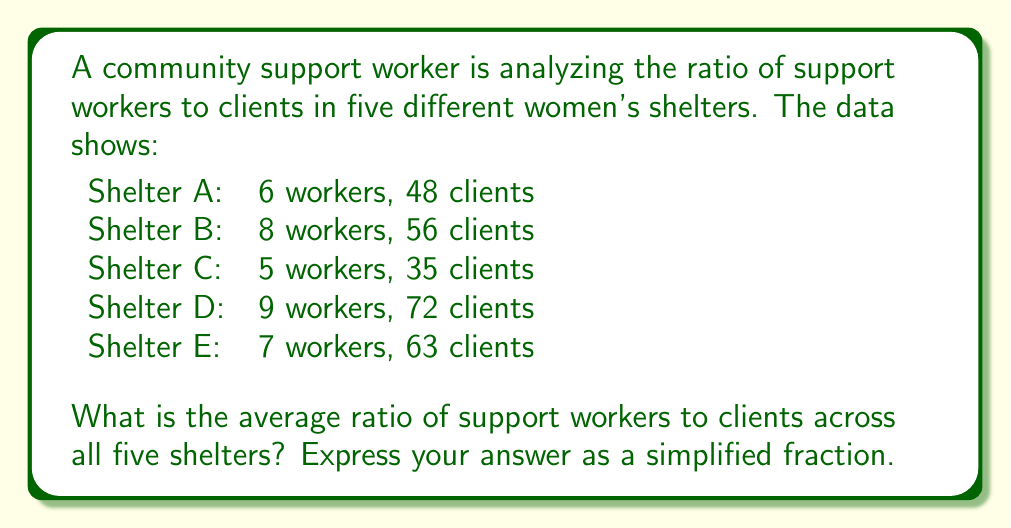Can you answer this question? 1) First, we need to calculate the ratio of workers to clients for each shelter:

   Shelter A: $\frac{6}{48} = \frac{1}{8}$
   Shelter B: $\frac{8}{56} = \frac{1}{7}$
   Shelter C: $\frac{5}{35} = \frac{1}{7}$
   Shelter D: $\frac{9}{72} = \frac{1}{8}$
   Shelter E: $\frac{7}{63} = \frac{1}{9}$

2) To find the average ratio, we sum these fractions and divide by the number of shelters:

   $$\frac{\frac{1}{8} + \frac{1}{7} + \frac{1}{7} + \frac{1}{8} + \frac{1}{9}}{5}$$

3) To add fractions with different denominators, we need a common denominator. The LCM of 7, 8, and 9 is 504:

   $$\frac{\frac{63}{504} + \frac{72}{504} + \frac{72}{504} + \frac{63}{504} + \frac{56}{504}}{5}$$

4) Adding the numerators:

   $$\frac{\frac{326}{504}}{5}$$

5) Simplifying:

   $$\frac{326}{2520}$$

6) This fraction can be reduced by dividing both numerator and denominator by 2:

   $$\frac{163}{1260}$$

This is the simplified average ratio of support workers to clients across all five shelters.
Answer: $\frac{163}{1260}$ 